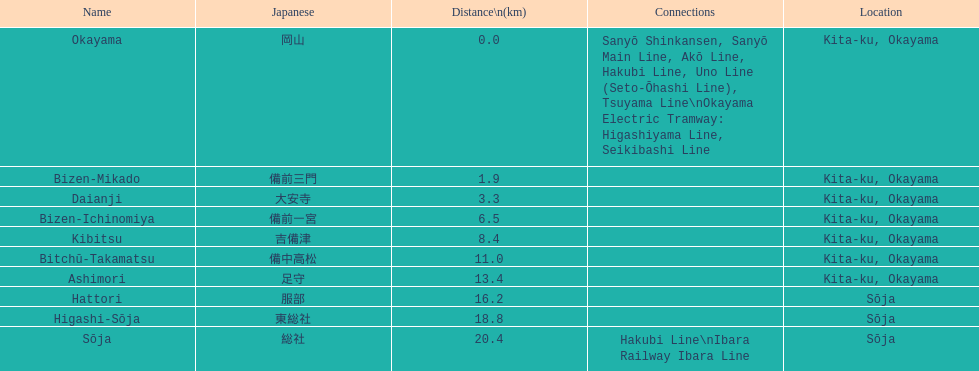Which has a distance less than 3.0 kilometers? Bizen-Mikado. 